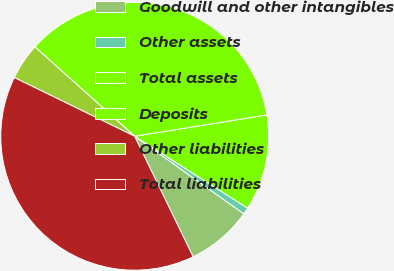<chart> <loc_0><loc_0><loc_500><loc_500><pie_chart><fcel>Goodwill and other intangibles<fcel>Other assets<fcel>Total assets<fcel>Deposits<fcel>Other liabilities<fcel>Total liabilities<nl><fcel>7.98%<fcel>0.82%<fcel>11.56%<fcel>35.83%<fcel>4.4%<fcel>39.41%<nl></chart> 